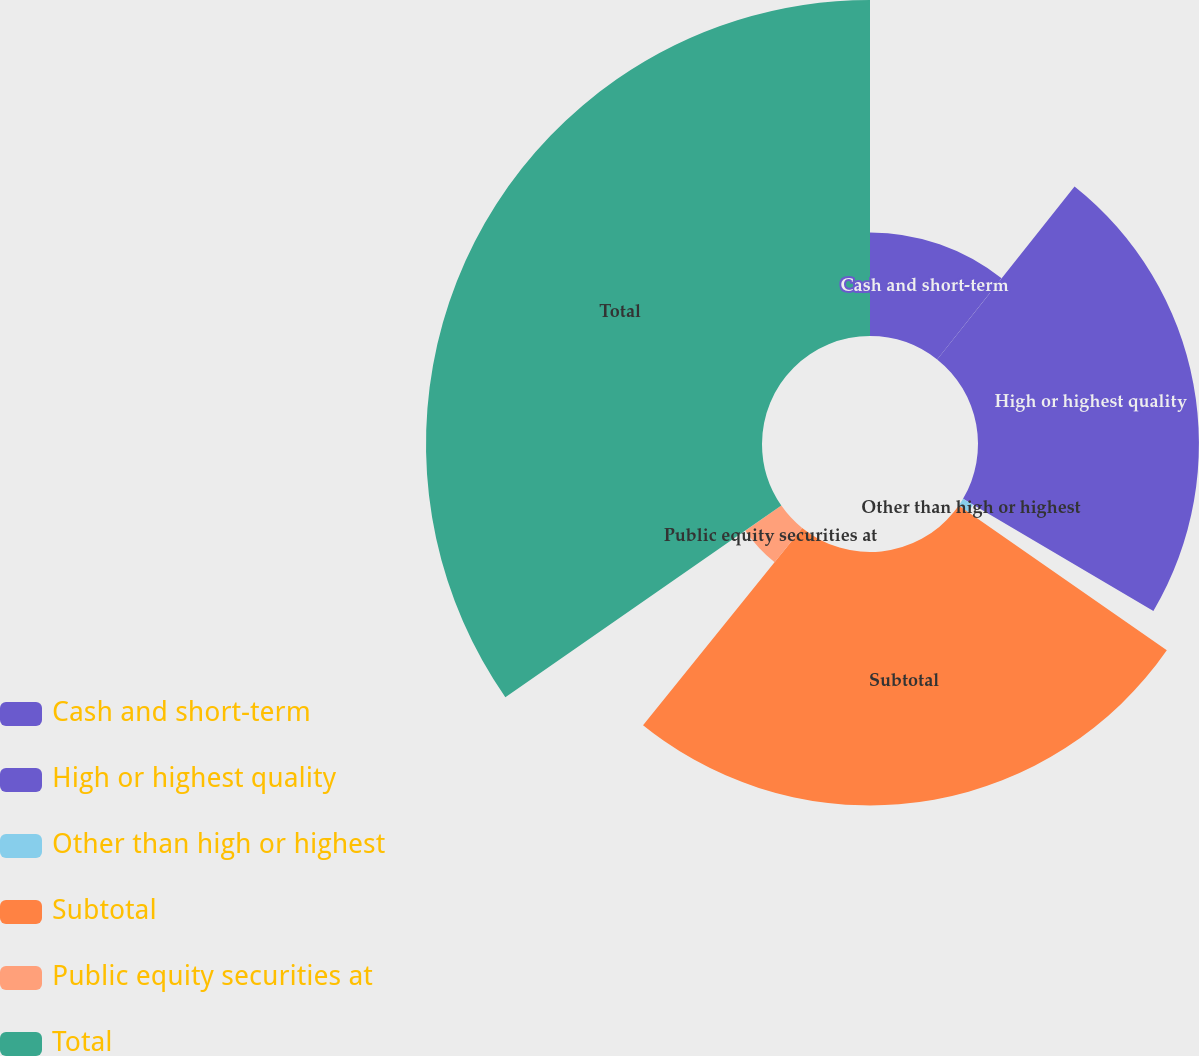Convert chart to OTSL. <chart><loc_0><loc_0><loc_500><loc_500><pie_chart><fcel>Cash and short-term<fcel>High or highest quality<fcel>Other than high or highest<fcel>Subtotal<fcel>Public equity securities at<fcel>Total<nl><fcel>10.68%<fcel>22.79%<fcel>1.19%<fcel>26.14%<fcel>4.53%<fcel>34.66%<nl></chart> 